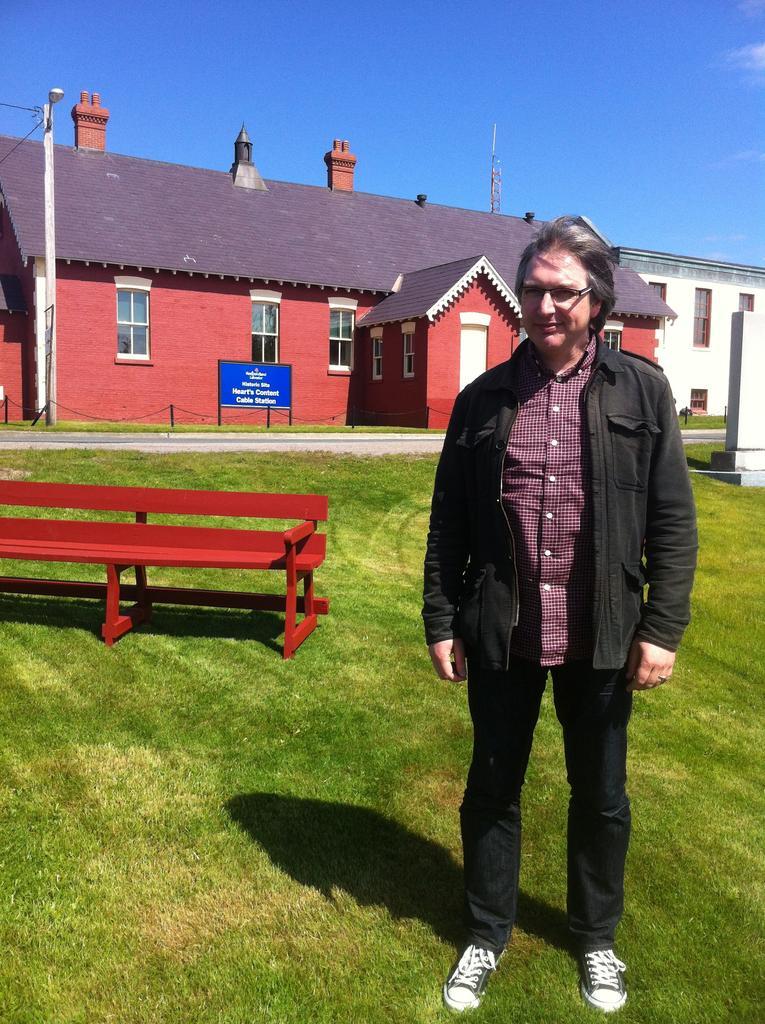Could you give a brief overview of what you see in this image? In this picture we can see man wore spectacle, jacket standing on grass and here in the background we can see bench, house with windows and banner, sky, pole. 